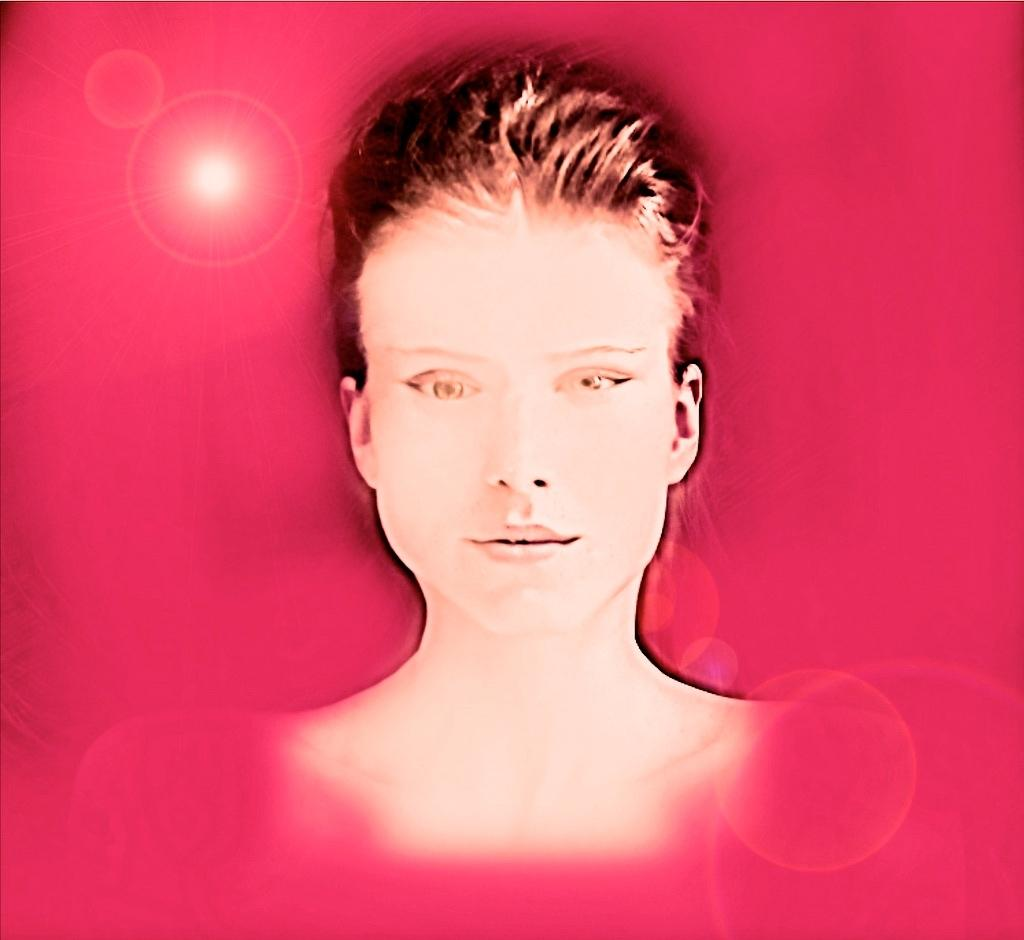What type of image is being described? The image is an animation. Who or what is the main subject in the image? There is a woman in the center of the image. What color is the background of the image? The background of the image is pink. What type of tank can be seen in the image? There is no tank present in the image; it features an animated woman with a pink background. What is the woman's nose doing in the image? The woman's nose is not performing any action in the image; it is simply a part of her animated character. 